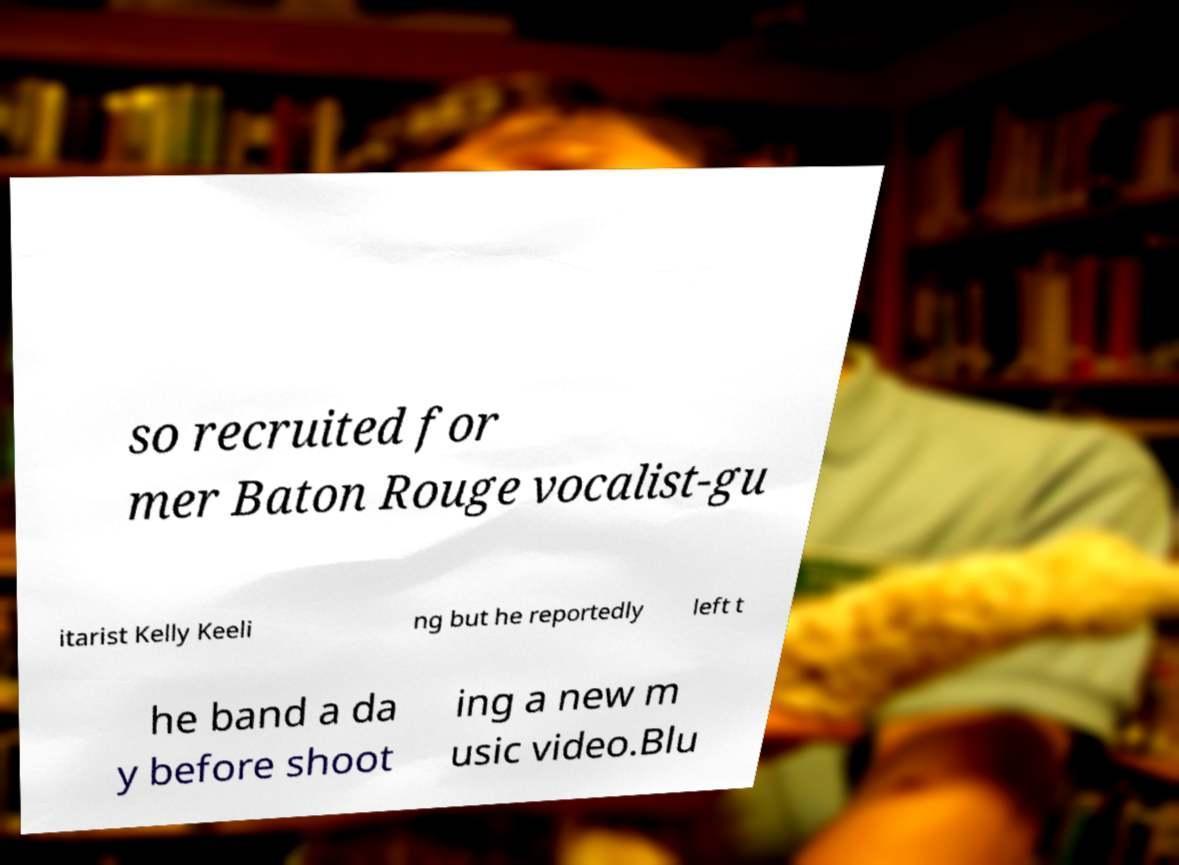Could you assist in decoding the text presented in this image and type it out clearly? so recruited for mer Baton Rouge vocalist-gu itarist Kelly Keeli ng but he reportedly left t he band a da y before shoot ing a new m usic video.Blu 